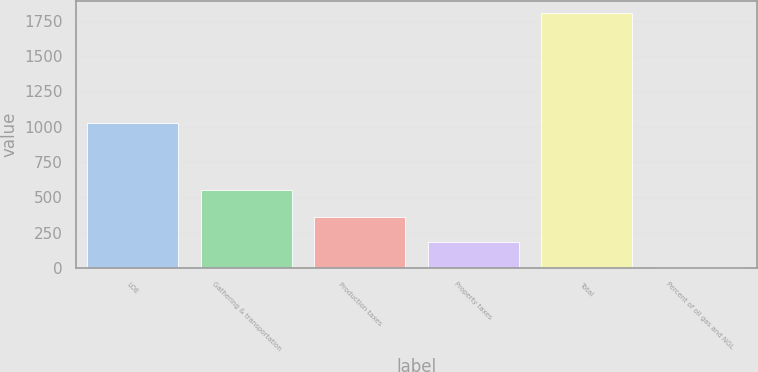<chart> <loc_0><loc_0><loc_500><loc_500><bar_chart><fcel>LOE<fcel>Gathering & transportation<fcel>Production taxes<fcel>Property taxes<fcel>Total<fcel>Percent of oil gas and NGL<nl><fcel>1027<fcel>555<fcel>363.4<fcel>183.45<fcel>1803<fcel>3.5<nl></chart> 